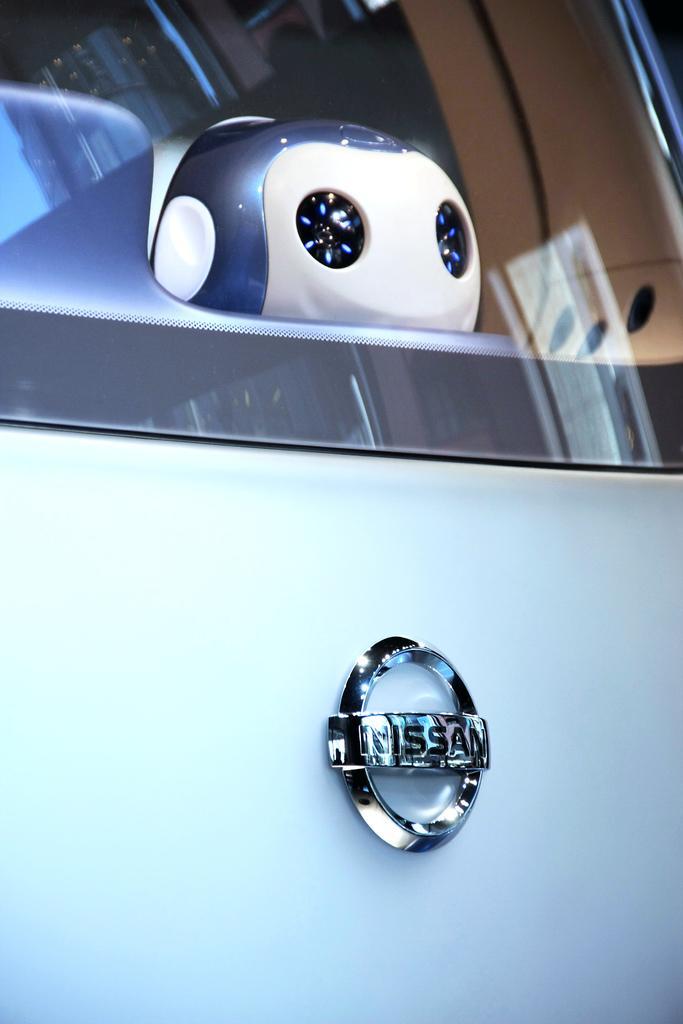Please provide a concise description of this image. In this picture we can see a car glass here, there is a logo here, here we can see a doll through the glass. 